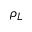<formula> <loc_0><loc_0><loc_500><loc_500>\rho _ { L }</formula> 